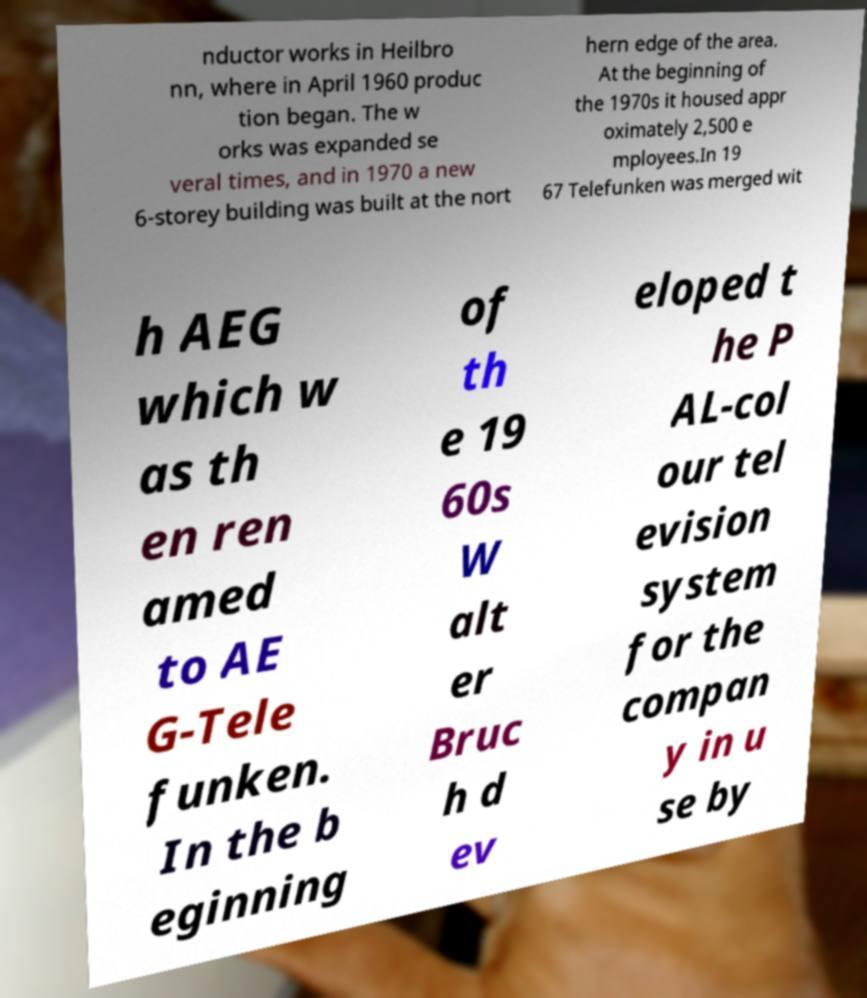Can you read and provide the text displayed in the image?This photo seems to have some interesting text. Can you extract and type it out for me? nductor works in Heilbro nn, where in April 1960 produc tion began. The w orks was expanded se veral times, and in 1970 a new 6-storey building was built at the nort hern edge of the area. At the beginning of the 1970s it housed appr oximately 2,500 e mployees.In 19 67 Telefunken was merged wit h AEG which w as th en ren amed to AE G-Tele funken. In the b eginning of th e 19 60s W alt er Bruc h d ev eloped t he P AL-col our tel evision system for the compan y in u se by 